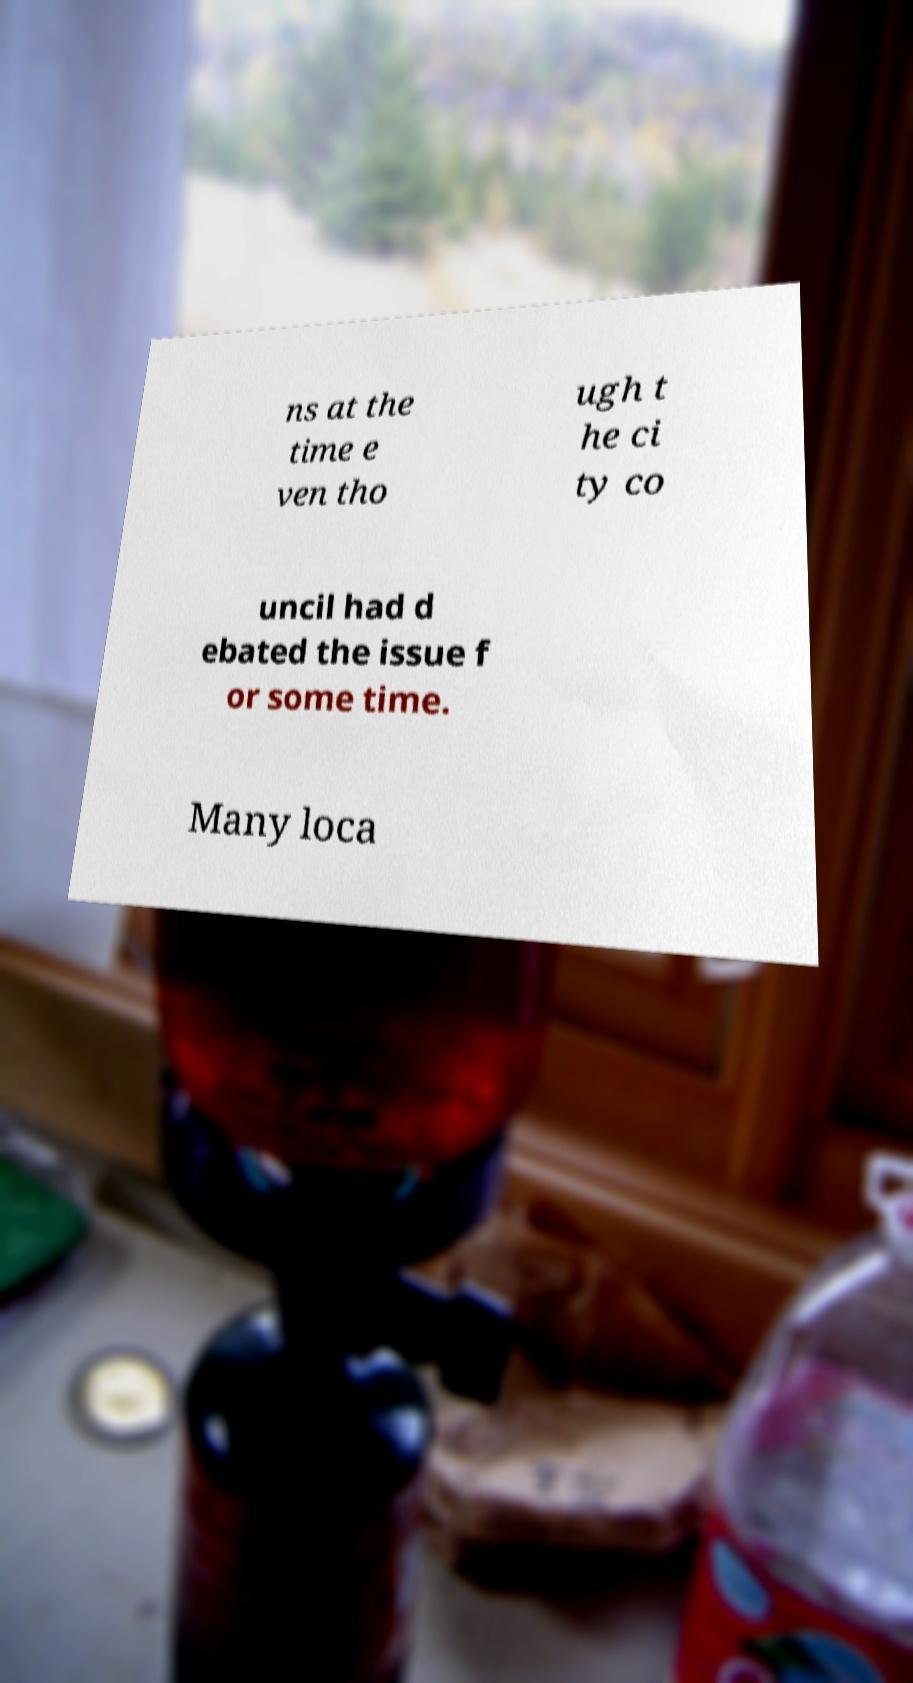For documentation purposes, I need the text within this image transcribed. Could you provide that? ns at the time e ven tho ugh t he ci ty co uncil had d ebated the issue f or some time. Many loca 